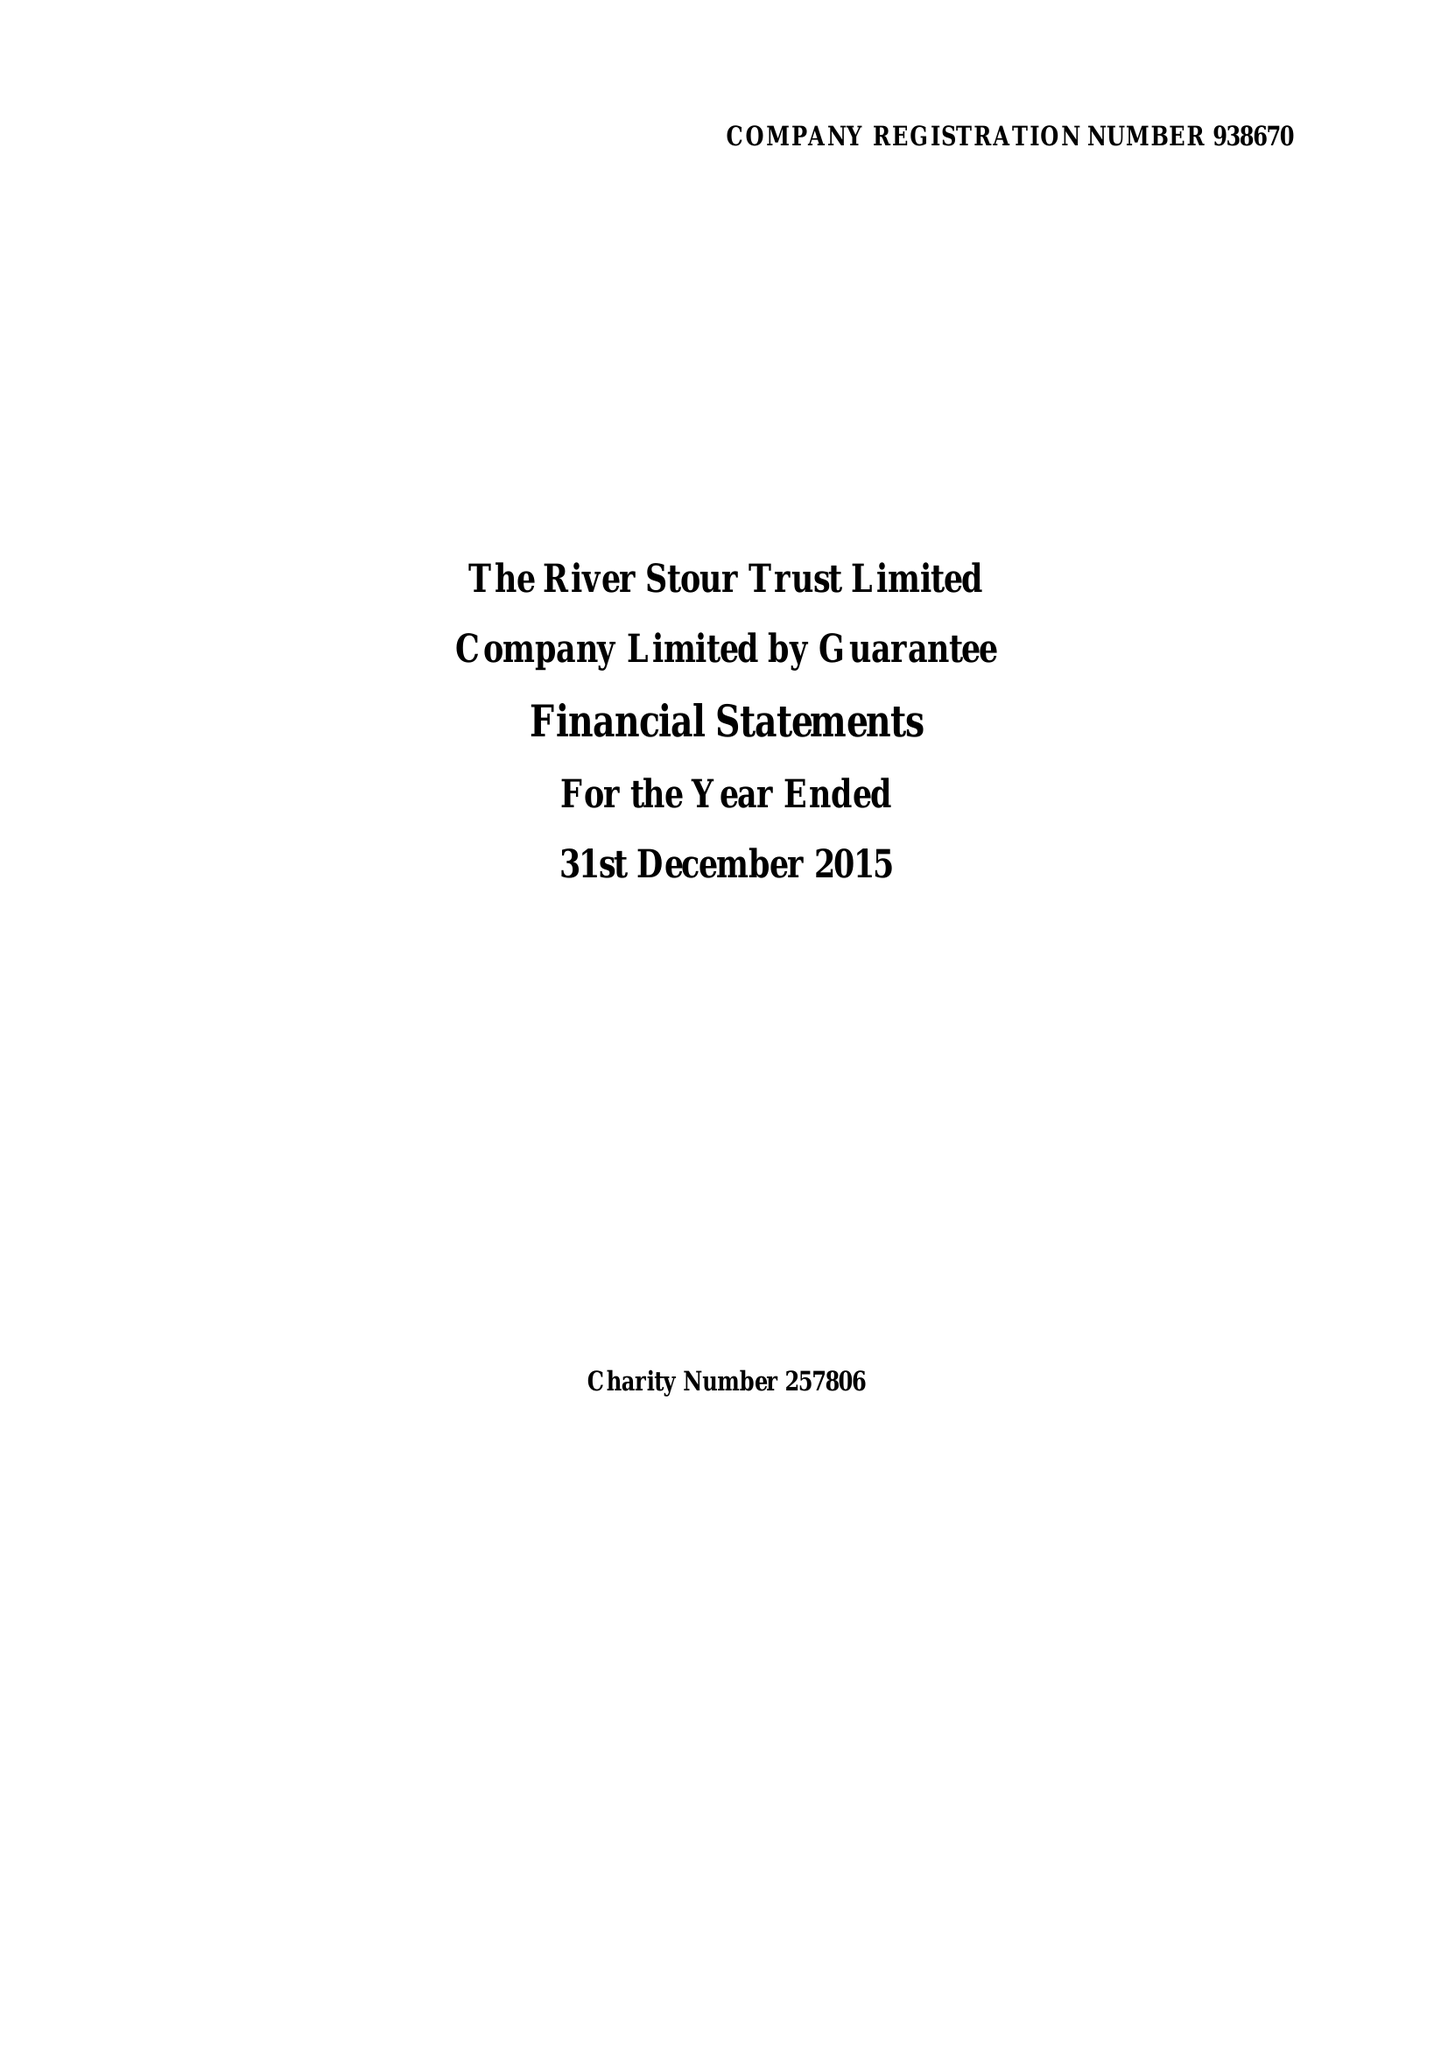What is the value for the address__post_town?
Answer the question using a single word or phrase. SUDBURY 